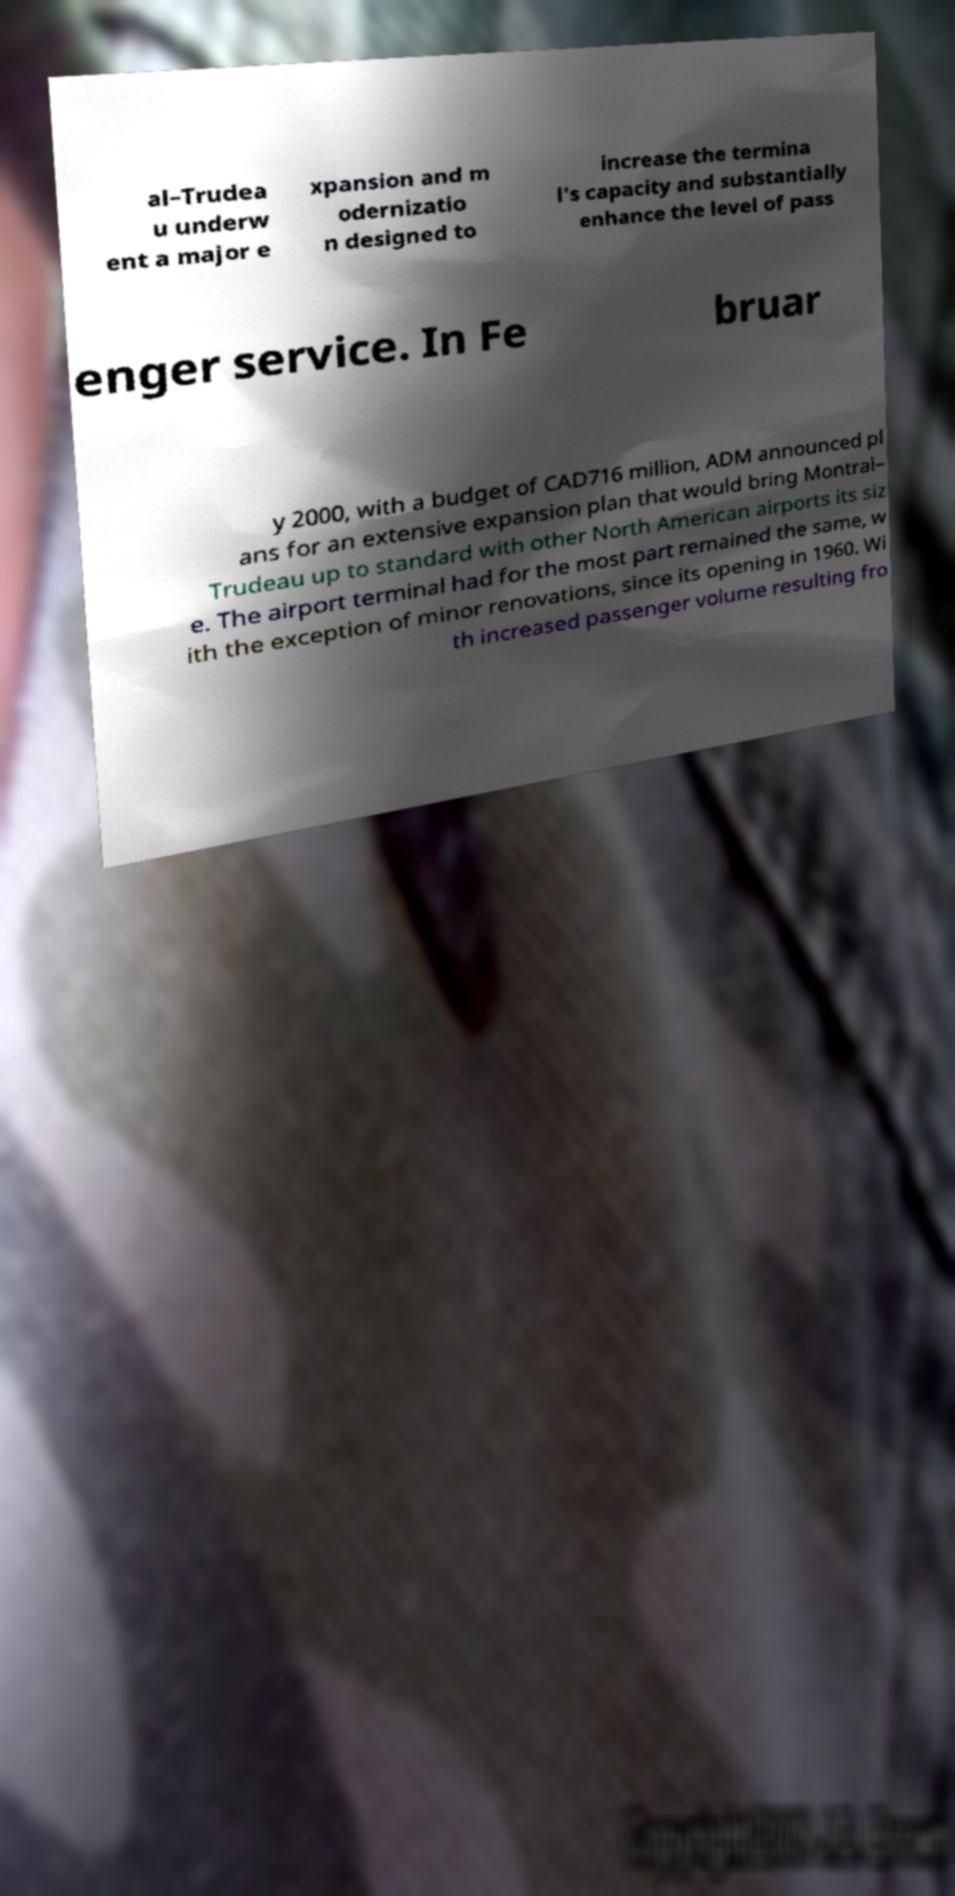Could you assist in decoding the text presented in this image and type it out clearly? al–Trudea u underw ent a major e xpansion and m odernizatio n designed to increase the termina l's capacity and substantially enhance the level of pass enger service. In Fe bruar y 2000, with a budget of CAD716 million, ADM announced pl ans for an extensive expansion plan that would bring Montral– Trudeau up to standard with other North American airports its siz e. The airport terminal had for the most part remained the same, w ith the exception of minor renovations, since its opening in 1960. Wi th increased passenger volume resulting fro 